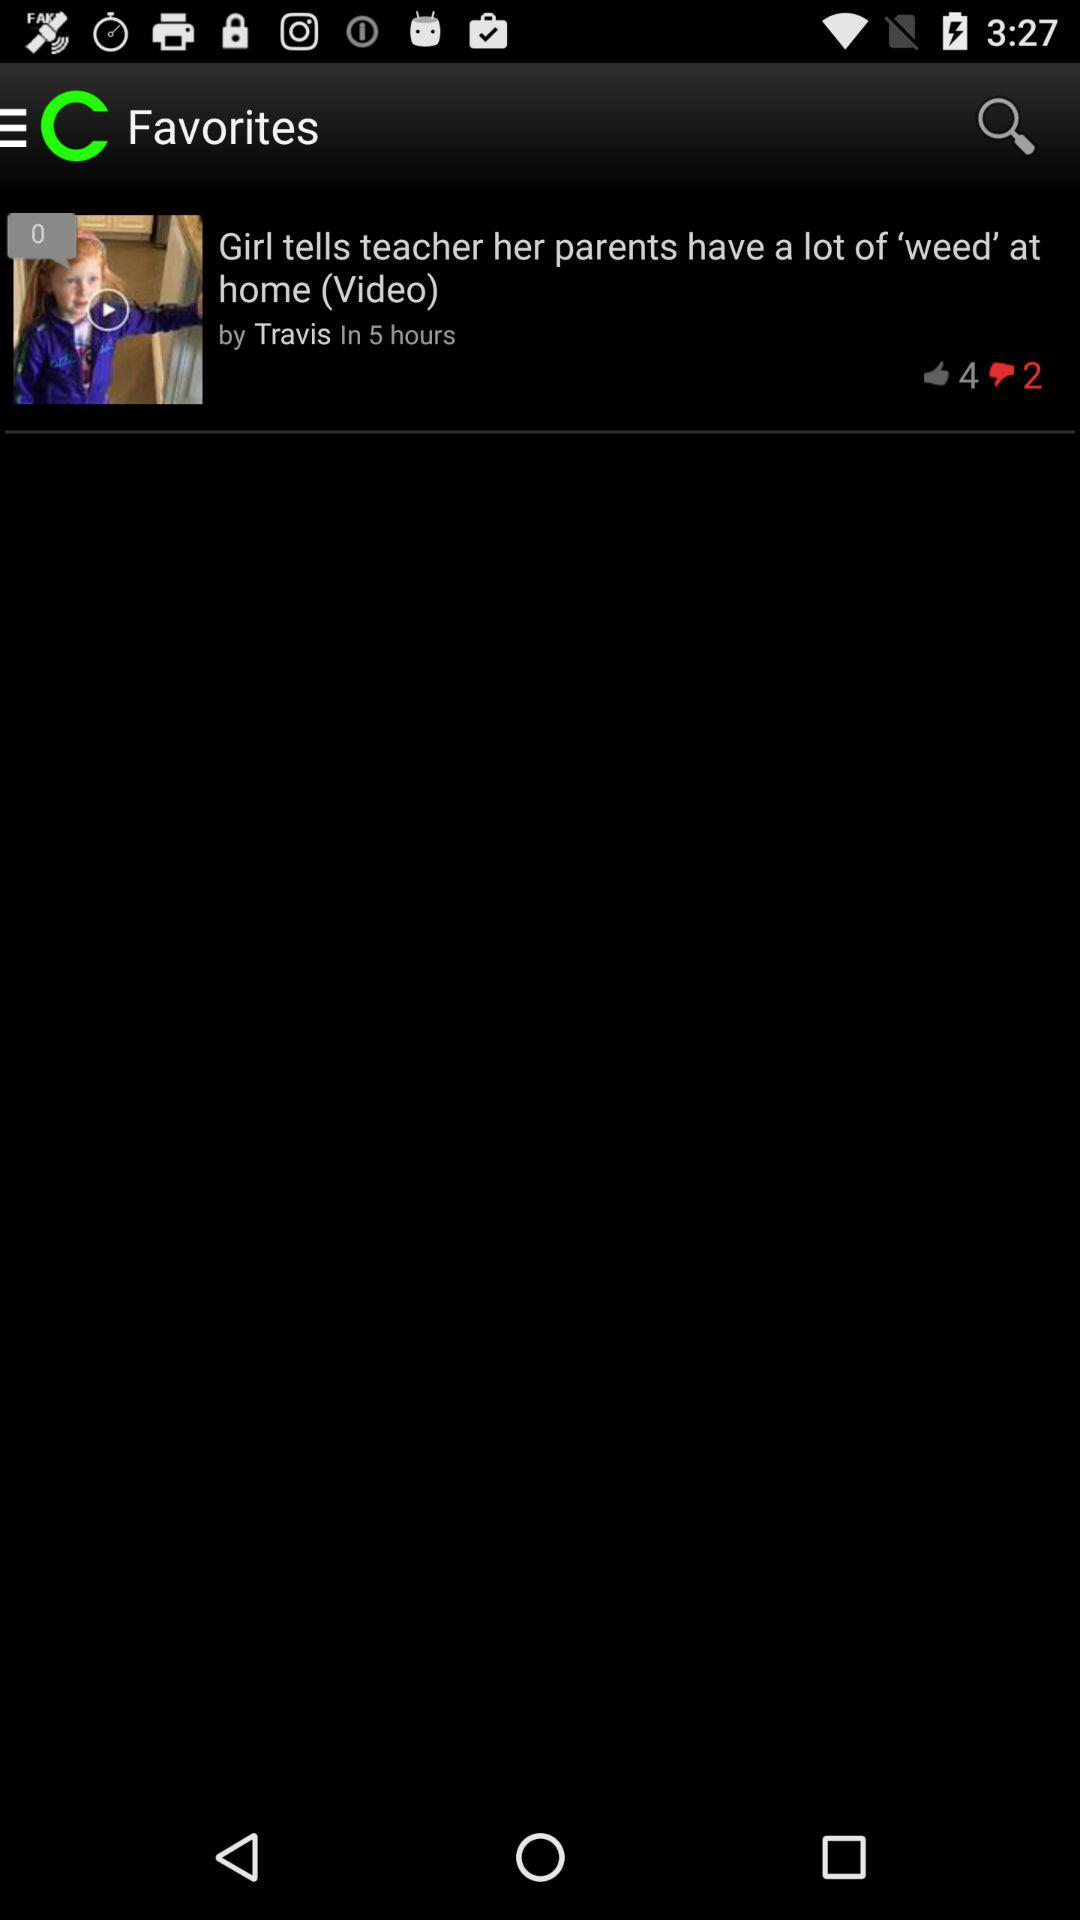How many more thumbs up than down does the video have?
Answer the question using a single word or phrase. 2 